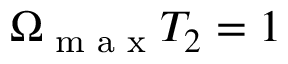<formula> <loc_0><loc_0><loc_500><loc_500>\Omega _ { \max } T _ { 2 } = 1</formula> 